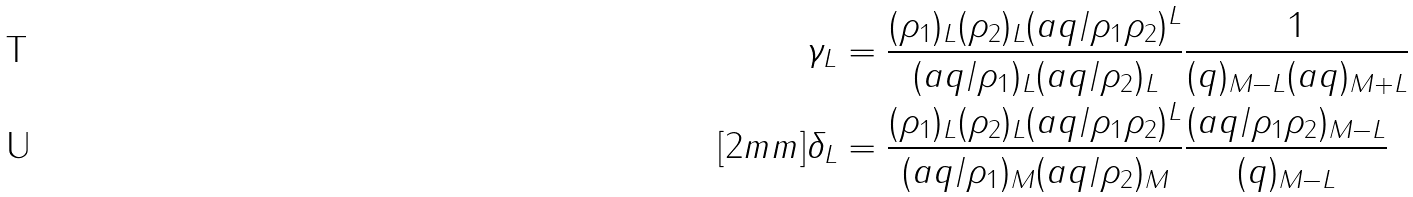<formula> <loc_0><loc_0><loc_500><loc_500>\gamma _ { L } & = \frac { ( \rho _ { 1 } ) _ { L } ( \rho _ { 2 } ) _ { L } ( a q / \rho _ { 1 } \rho _ { 2 } ) ^ { L } } { ( a q / \rho _ { 1 } ) _ { L } ( a q / \rho _ { 2 } ) _ { L } } \frac { 1 } { ( q ) _ { M - L } ( a q ) _ { M + L } } \\ [ 2 m m ] \delta _ { L } & = \frac { ( \rho _ { 1 } ) _ { L } ( \rho _ { 2 } ) _ { L } ( a q / \rho _ { 1 } \rho _ { 2 } ) ^ { L } } { ( a q / \rho _ { 1 } ) _ { M } ( a q / \rho _ { 2 } ) _ { M } } \frac { ( a q / \rho _ { 1 } \rho _ { 2 } ) _ { M - L } } { ( q ) _ { M - L } }</formula> 